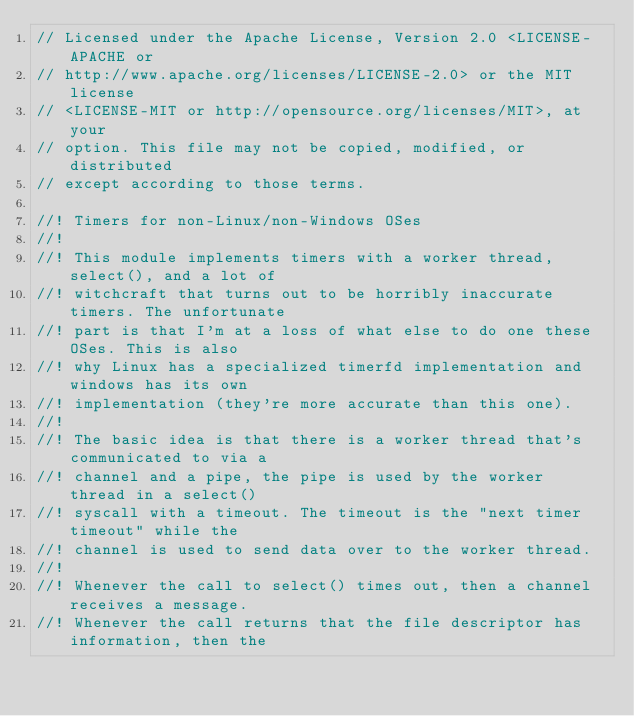Convert code to text. <code><loc_0><loc_0><loc_500><loc_500><_Rust_>// Licensed under the Apache License, Version 2.0 <LICENSE-APACHE or
// http://www.apache.org/licenses/LICENSE-2.0> or the MIT license
// <LICENSE-MIT or http://opensource.org/licenses/MIT>, at your
// option. This file may not be copied, modified, or distributed
// except according to those terms.

//! Timers for non-Linux/non-Windows OSes
//!
//! This module implements timers with a worker thread, select(), and a lot of
//! witchcraft that turns out to be horribly inaccurate timers. The unfortunate
//! part is that I'm at a loss of what else to do one these OSes. This is also
//! why Linux has a specialized timerfd implementation and windows has its own
//! implementation (they're more accurate than this one).
//!
//! The basic idea is that there is a worker thread that's communicated to via a
//! channel and a pipe, the pipe is used by the worker thread in a select()
//! syscall with a timeout. The timeout is the "next timer timeout" while the
//! channel is used to send data over to the worker thread.
//!
//! Whenever the call to select() times out, then a channel receives a message.
//! Whenever the call returns that the file descriptor has information, then the</code> 